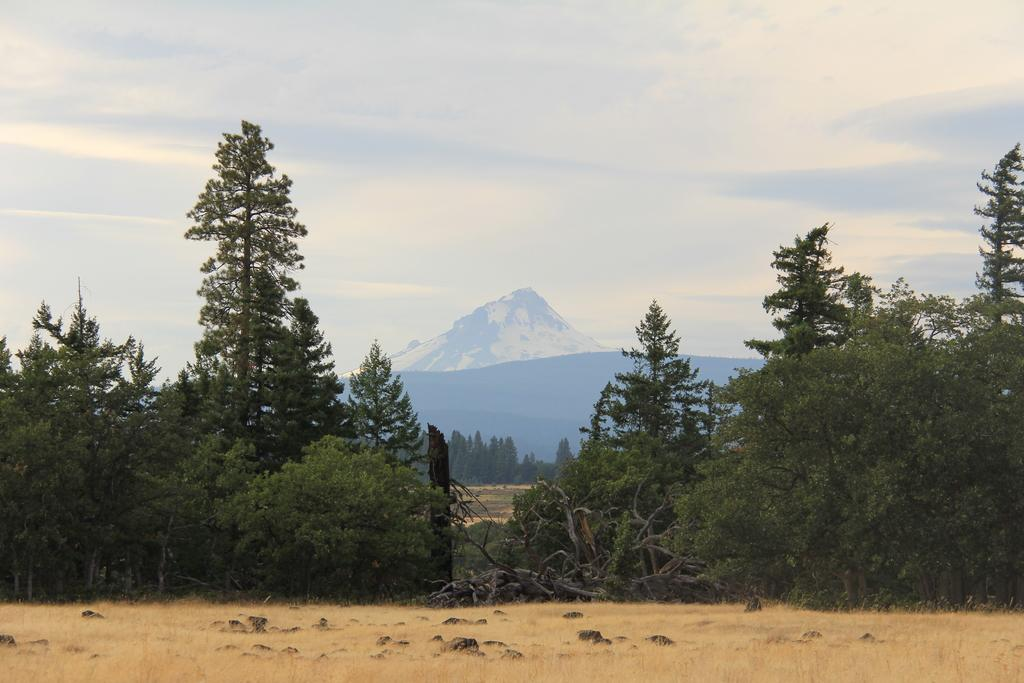What type of vegetation can be seen in the image? There are trees in the image. What is present at the bottom of the image? There are stones at the bottom of the image. What can be seen in the distance in the image? There are hills visible in the background of the image. What is visible in the sky in the background of the image? There are clouds in the sky in the background of the image. Where is the market located in the image? There is no market present in the image. What type of room is visible in the image? There is no room visible in the image; it is an outdoor scene with trees, stones, hills, and clouds. 